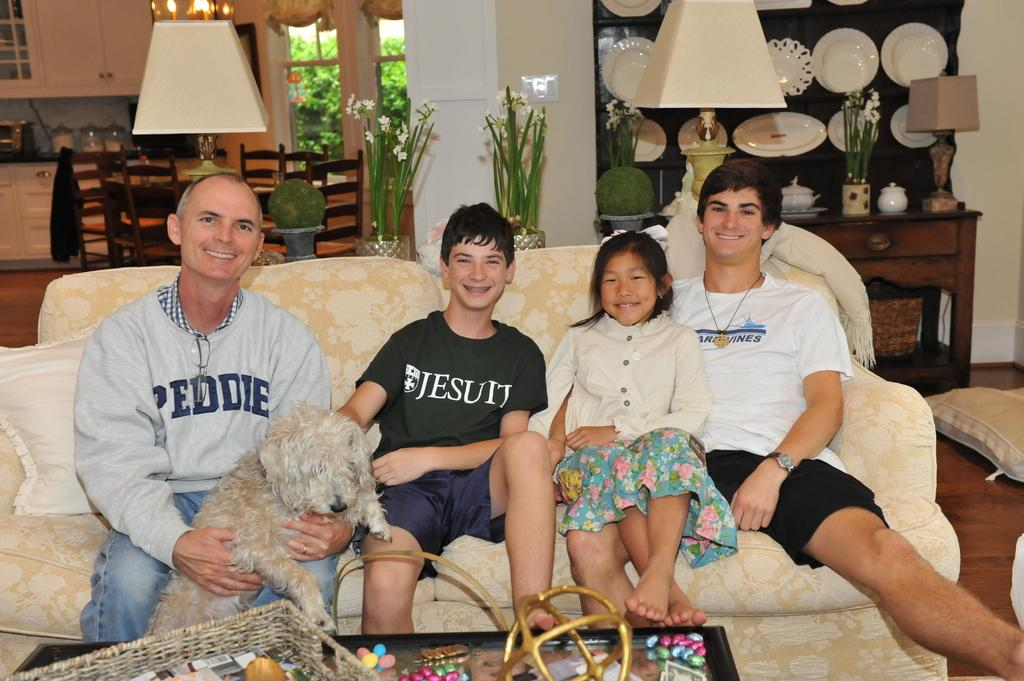How many people are sitting on the sofa in the image? There are four persons sitting on the sofa in the image. What is one person doing with a pet? One person is holding a dog. What type of furniture can be seen in the background? There are chairs in the background. What object provides light in the image? There is a lamp in the image. What architectural feature is present in the image? There is a pillar in the image. What type of reaction does the dog have to the pleasure of being held by the person? There is no indication of the dog's reaction or pleasure in the image, as it only shows the person holding the dog. What is the condition of the person's neck in the image? There is no information about the person's neck in the image. 